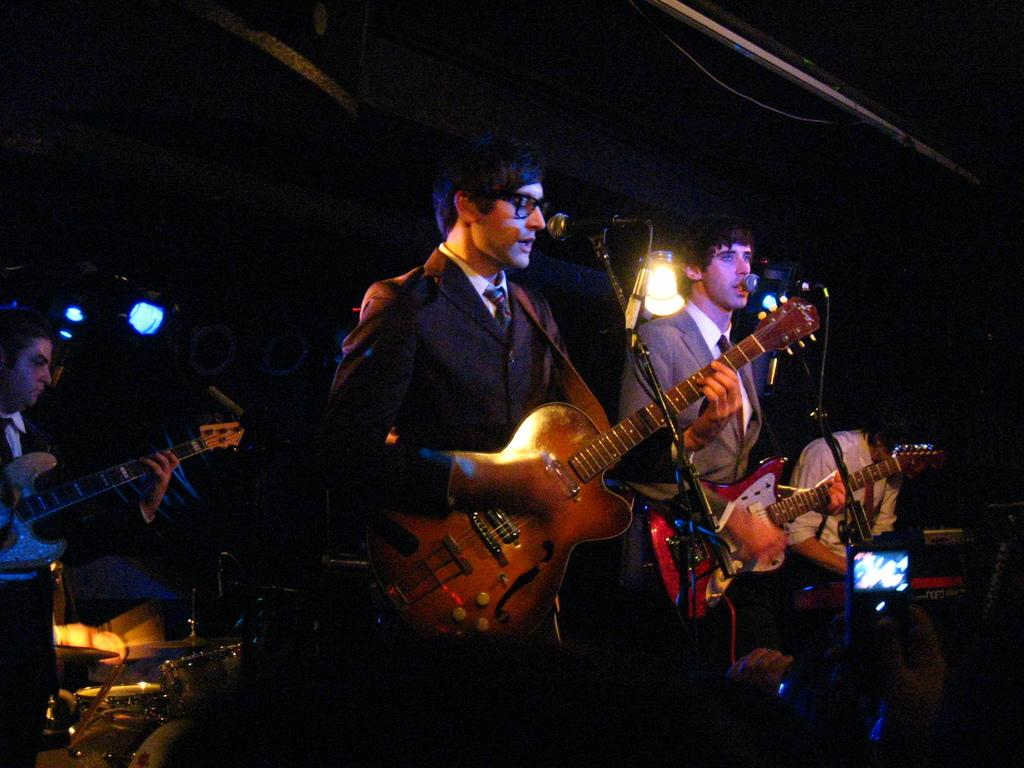How many people are in the image? There are two persons in the image. What are the persons doing in the image? The persons are standing, and one person is playing a guitar. What is in front of the guitar player? There is a microphone in front of the guitar player. What can be seen attached to the roof in the image? There are lights attached to the roof, and they are focusing lights. What other musical instrument is being played in the image? One person is playing a musical instrument, but it is not specified which one. Can you identify any electronic devices in the image? Yes, there is a mobile phone visible in the image. What type of whip is the fireman using to control the crowd in the image? There is no fireman or crowd present in the image, and therefore no whip or crowd control can be observed. 